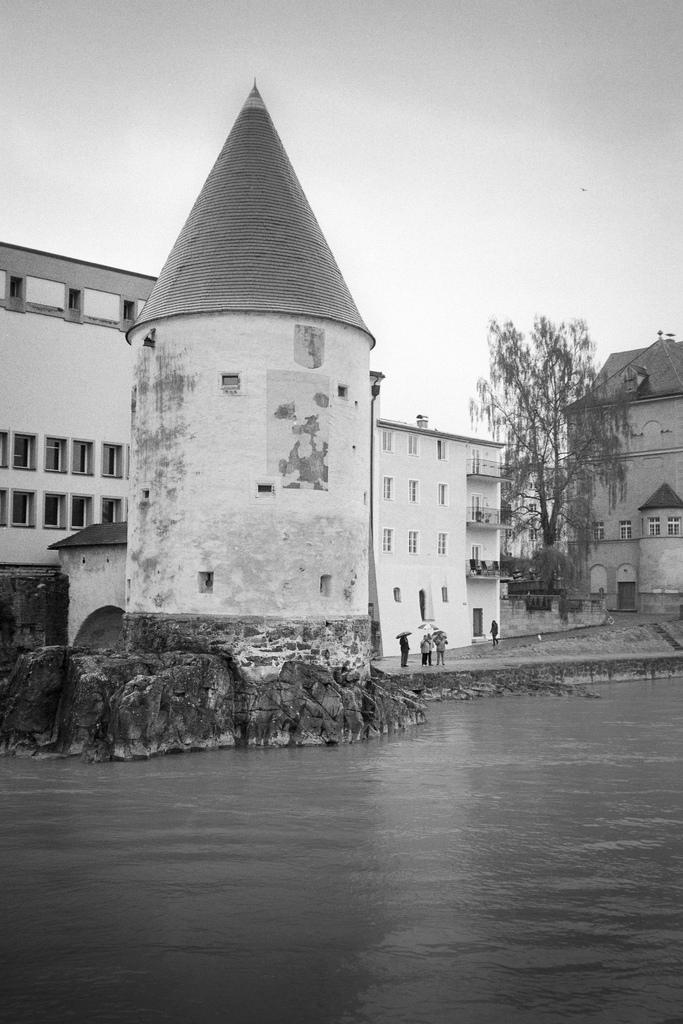What type of structures can be seen in the image? There are buildings in the image. What architectural elements are present in the image? There are walls and windows in the image. What type of vegetation is visible in the image? There is a tree in the image. Who or what is present in the image? There are people in the image. What objects are being used by the people in the image? There are umbrellas in the image. What can be seen at the bottom of the image? There is water visible at the bottom of the image. What is visible in the background of the image? The sky is visible in the background of the image. How many bushes are present in the image? There are no bushes mentioned or visible in the image. What type of trees can be seen pushing the buildings in the image? There are no trees pushing the buildings in the image, and no trees are mentioned as having the ability to push anything. 